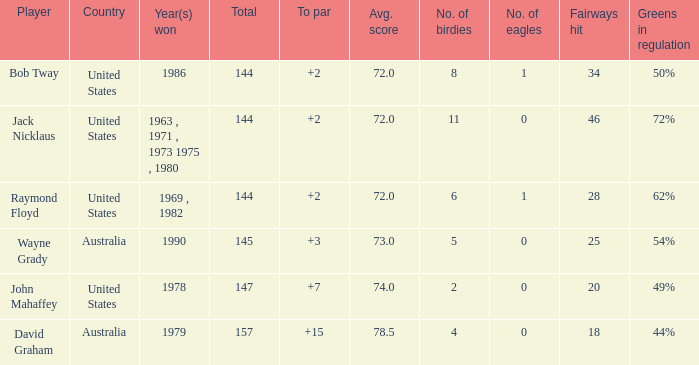Could you parse the entire table? {'header': ['Player', 'Country', 'Year(s) won', 'Total', 'To par', 'Avg. score', 'No. of birdies', 'No. of eagles', 'Fairways hit', 'Greens in regulation'], 'rows': [['Bob Tway', 'United States', '1986', '144', '+2', '72.0', '8', '1', '34', '50%'], ['Jack Nicklaus', 'United States', '1963 , 1971 , 1973 1975 , 1980', '144', '+2', '72.0', '11', '0', '46', '72%'], ['Raymond Floyd', 'United States', '1969 , 1982', '144', '+2', '72.0', '6', '1', '28', '62%'], ['Wayne Grady', 'Australia', '1990', '145', '+3', '73.0', '5', '0', '25', '54%'], ['John Mahaffey', 'United States', '1978', '147', '+7', '74.0', '2', '0', '20', '49%'], ['David Graham', 'Australia', '1979', '157', '+15', '78.5', '4', '0', '18', '44%']]} What was the average round score of the player who won in 1978? 147.0. 